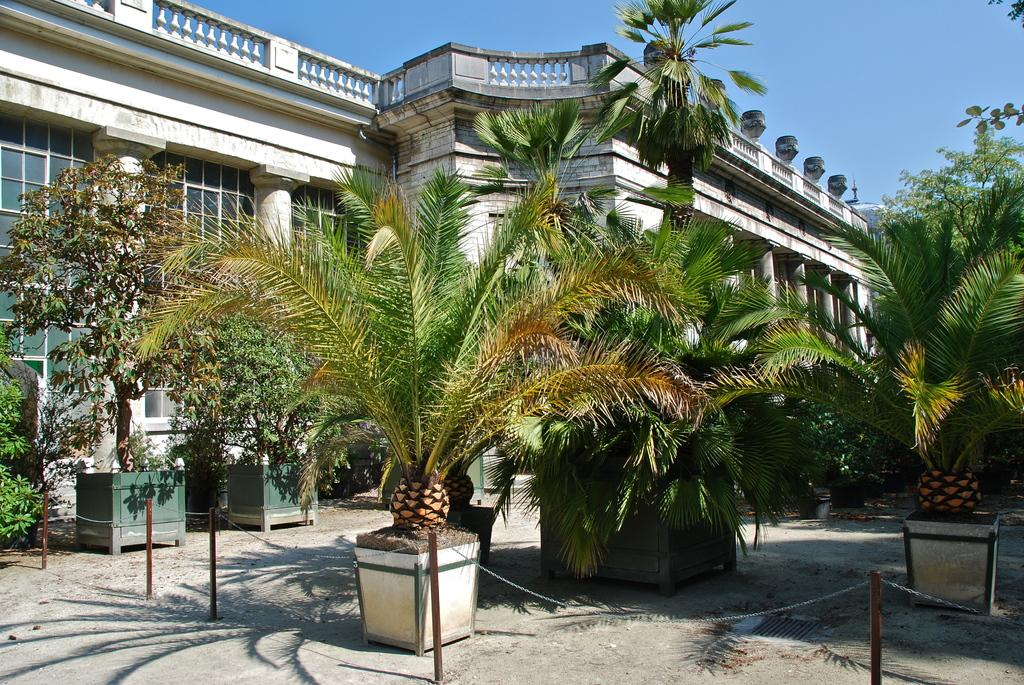What type of vegetation can be seen in the middle of the image? There are trees in the middle of the image. What type of structure is visible in the background of the image? There is a building in the background of the image. What is visible at the top of the image? The sky is visible at the top of the image. What type of drug is being used by the passenger in the image? There is no reference to a passenger or drug in the image, so it is not possible to answer that question. 